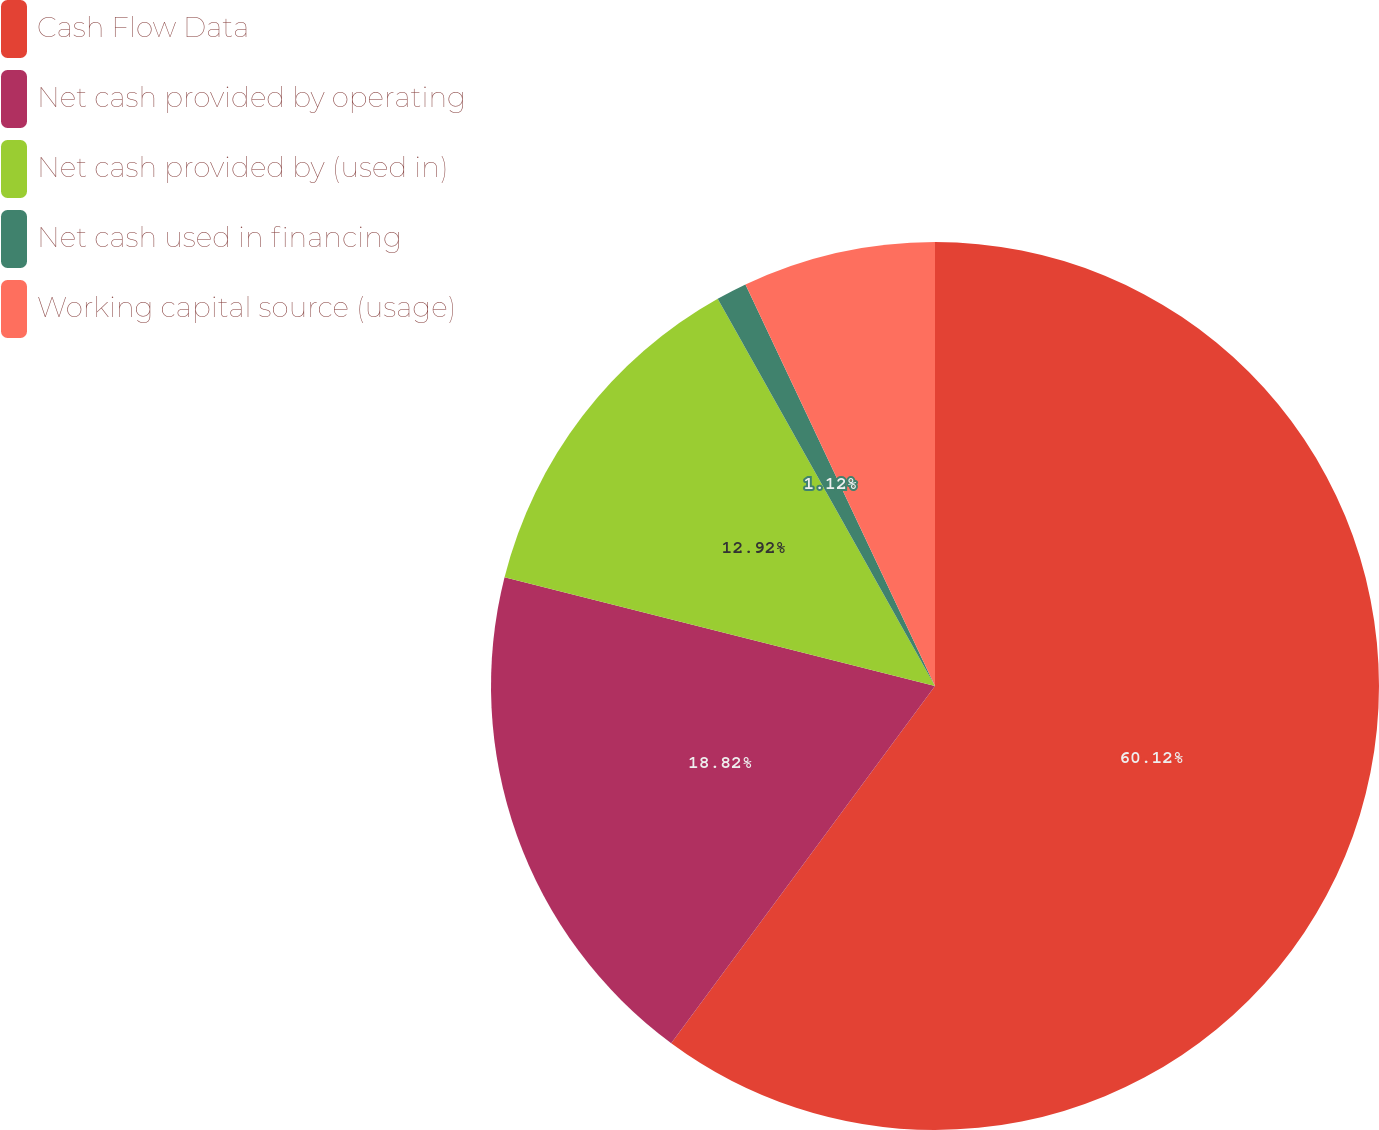Convert chart to OTSL. <chart><loc_0><loc_0><loc_500><loc_500><pie_chart><fcel>Cash Flow Data<fcel>Net cash provided by operating<fcel>Net cash provided by (used in)<fcel>Net cash used in financing<fcel>Working capital source (usage)<nl><fcel>60.13%<fcel>18.82%<fcel>12.92%<fcel>1.12%<fcel>7.02%<nl></chart> 